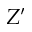Convert formula to latex. <formula><loc_0><loc_0><loc_500><loc_500>Z ^ { \prime }</formula> 